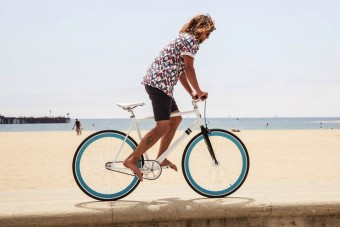What kind of activity is the person in the image doing? The person in the image is riding a bicycle along what appears to be a seaside promenade. What suggests that this is a seaside location? The sandy beach in the background and the presence of a large body of water resembling the sea imply a seaside location. 